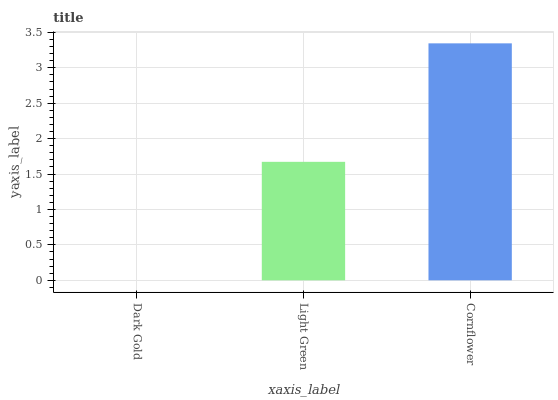Is Dark Gold the minimum?
Answer yes or no. Yes. Is Cornflower the maximum?
Answer yes or no. Yes. Is Light Green the minimum?
Answer yes or no. No. Is Light Green the maximum?
Answer yes or no. No. Is Light Green greater than Dark Gold?
Answer yes or no. Yes. Is Dark Gold less than Light Green?
Answer yes or no. Yes. Is Dark Gold greater than Light Green?
Answer yes or no. No. Is Light Green less than Dark Gold?
Answer yes or no. No. Is Light Green the high median?
Answer yes or no. Yes. Is Light Green the low median?
Answer yes or no. Yes. Is Cornflower the high median?
Answer yes or no. No. Is Dark Gold the low median?
Answer yes or no. No. 